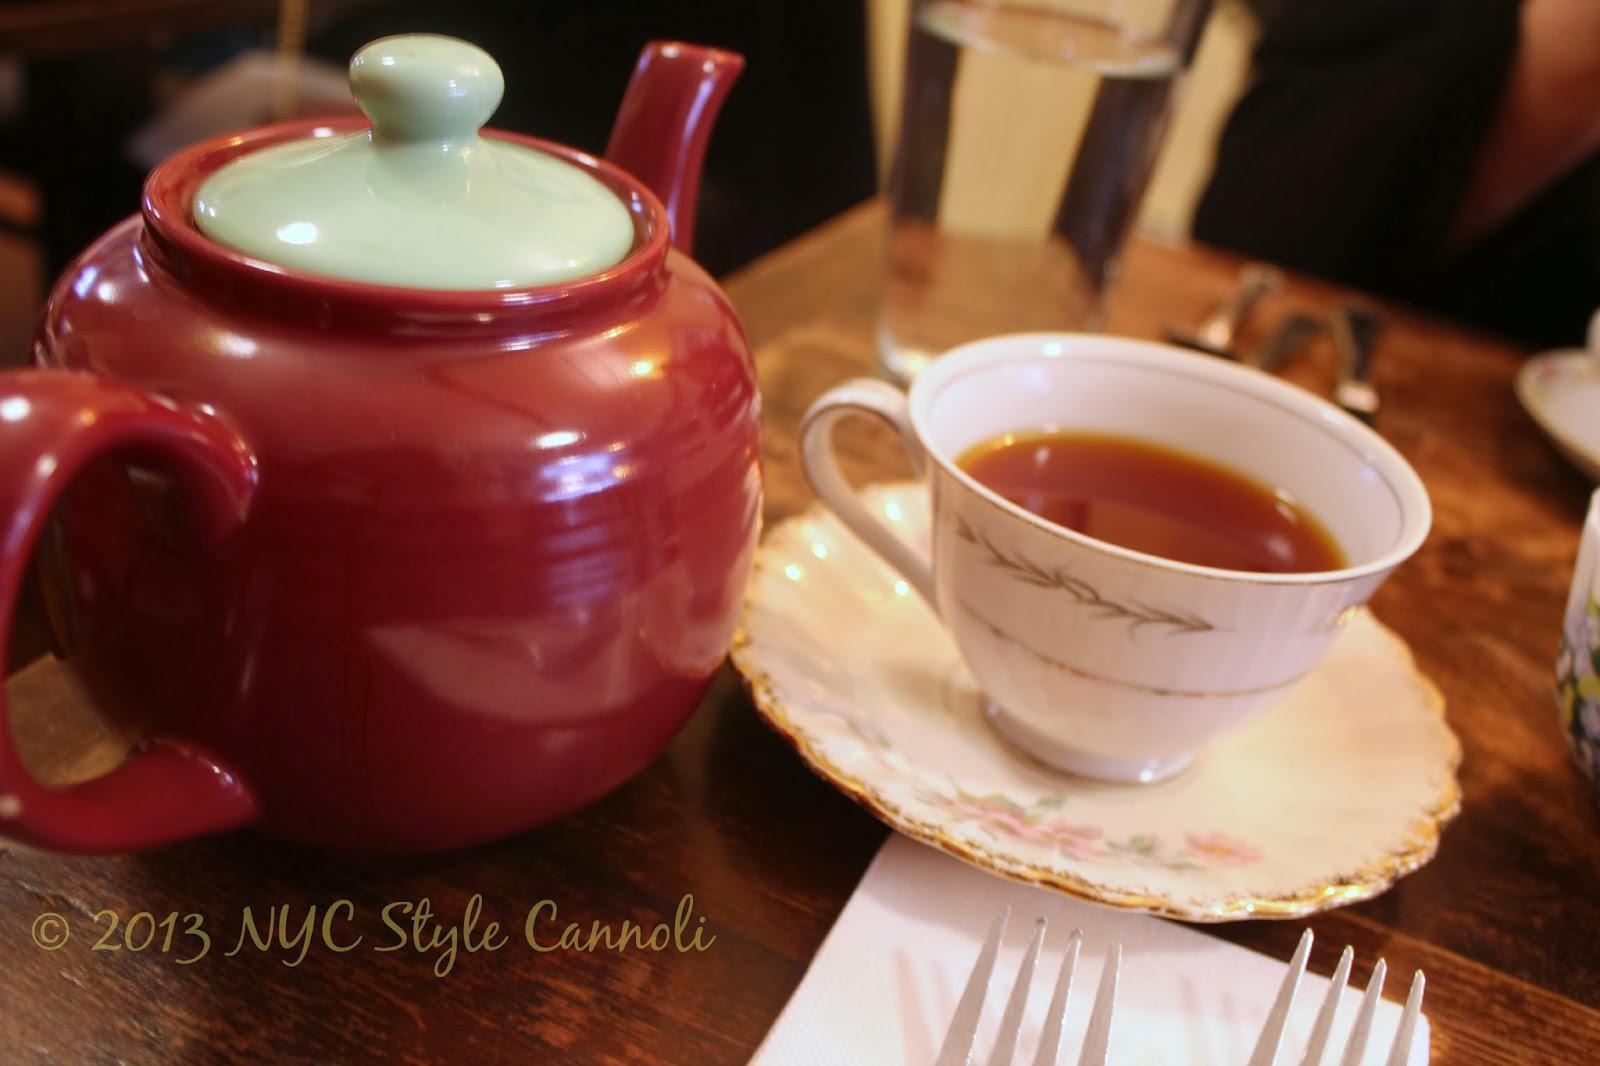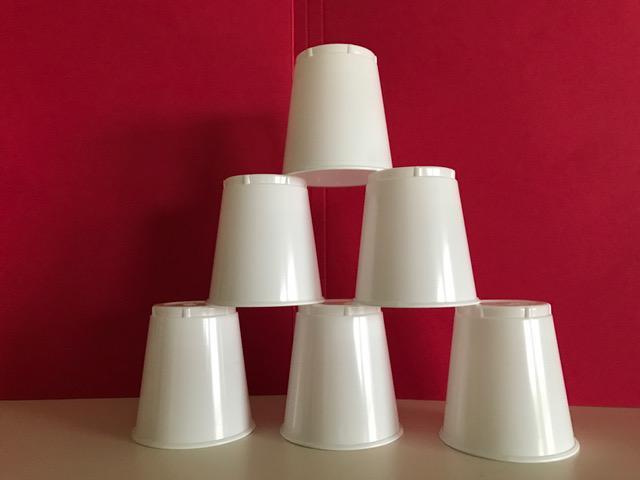The first image is the image on the left, the second image is the image on the right. For the images shown, is this caption "Some cups are made of plastic." true? Answer yes or no. Yes. 